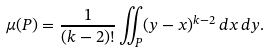<formula> <loc_0><loc_0><loc_500><loc_500>\mu ( P ) = \frac { 1 } { ( k - 2 ) ! } \iint _ { P } ( y - x ) ^ { k - 2 } \, d x \, d y .</formula> 